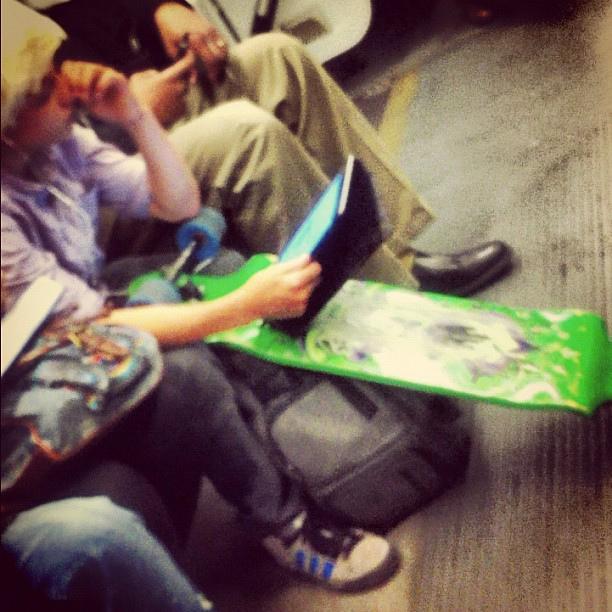What color is the skateboard?
Concise answer only. Green. Which hand holds the tablet?
Quick response, please. Right. How many blue stripes are on the white shoe?
Quick response, please. 3. 